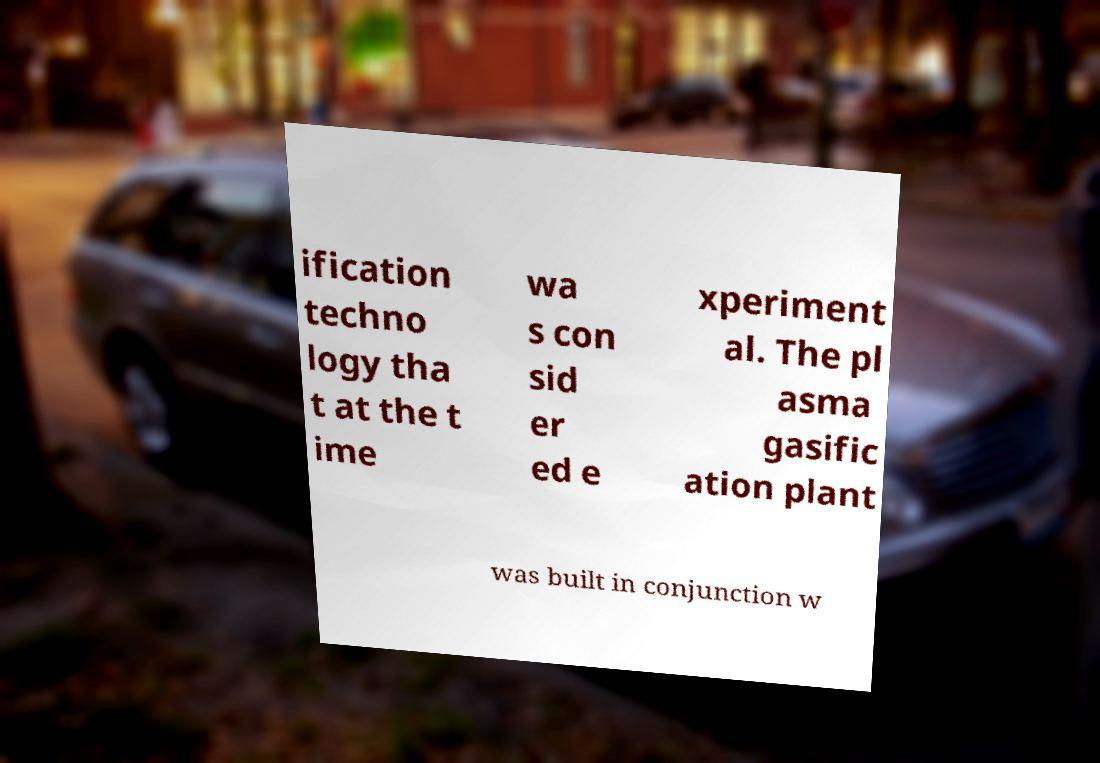What messages or text are displayed in this image? I need them in a readable, typed format. ification techno logy tha t at the t ime wa s con sid er ed e xperiment al. The pl asma gasific ation plant was built in conjunction w 